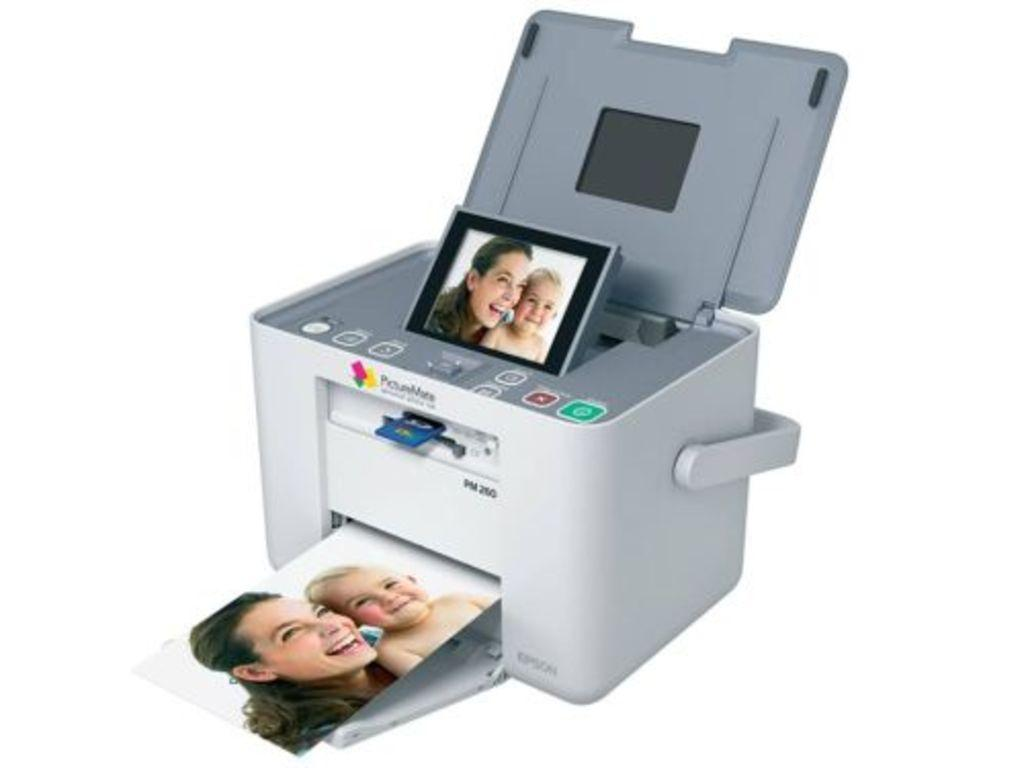What type of device is present in the image? There is a printer in the image. What else can be seen in the image besides the printer? There are photos in the image. Can you describe the content of one of the photos? The photo contains a woman and a baby, and they are both smiling. What type of beef is being prepared in the image? There is no beef present in the image; it features a printer and photos. What thrilling activity is taking place in the image? There is no thrilling activity depicted in the image; it shows a printer and photos of a smiling woman and baby. 